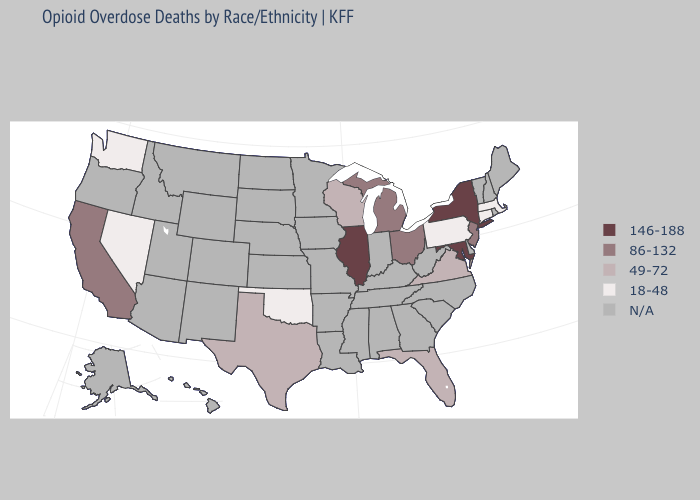What is the value of New Jersey?
Answer briefly. 86-132. Does the first symbol in the legend represent the smallest category?
Keep it brief. No. Does the map have missing data?
Give a very brief answer. Yes. Which states have the highest value in the USA?
Short answer required. Illinois, Maryland, New York. What is the value of Delaware?
Keep it brief. N/A. What is the value of Idaho?
Quick response, please. N/A. Which states hav the highest value in the West?
Keep it brief. California. Among the states that border New Jersey , which have the highest value?
Write a very short answer. New York. What is the value of Maine?
Short answer required. N/A. What is the lowest value in states that border Texas?
Quick response, please. 18-48. Name the states that have a value in the range 18-48?
Short answer required. Connecticut, Massachusetts, Nevada, Oklahoma, Pennsylvania, Washington. Is the legend a continuous bar?
Quick response, please. No. What is the lowest value in states that border Virginia?
Quick response, please. 146-188. 